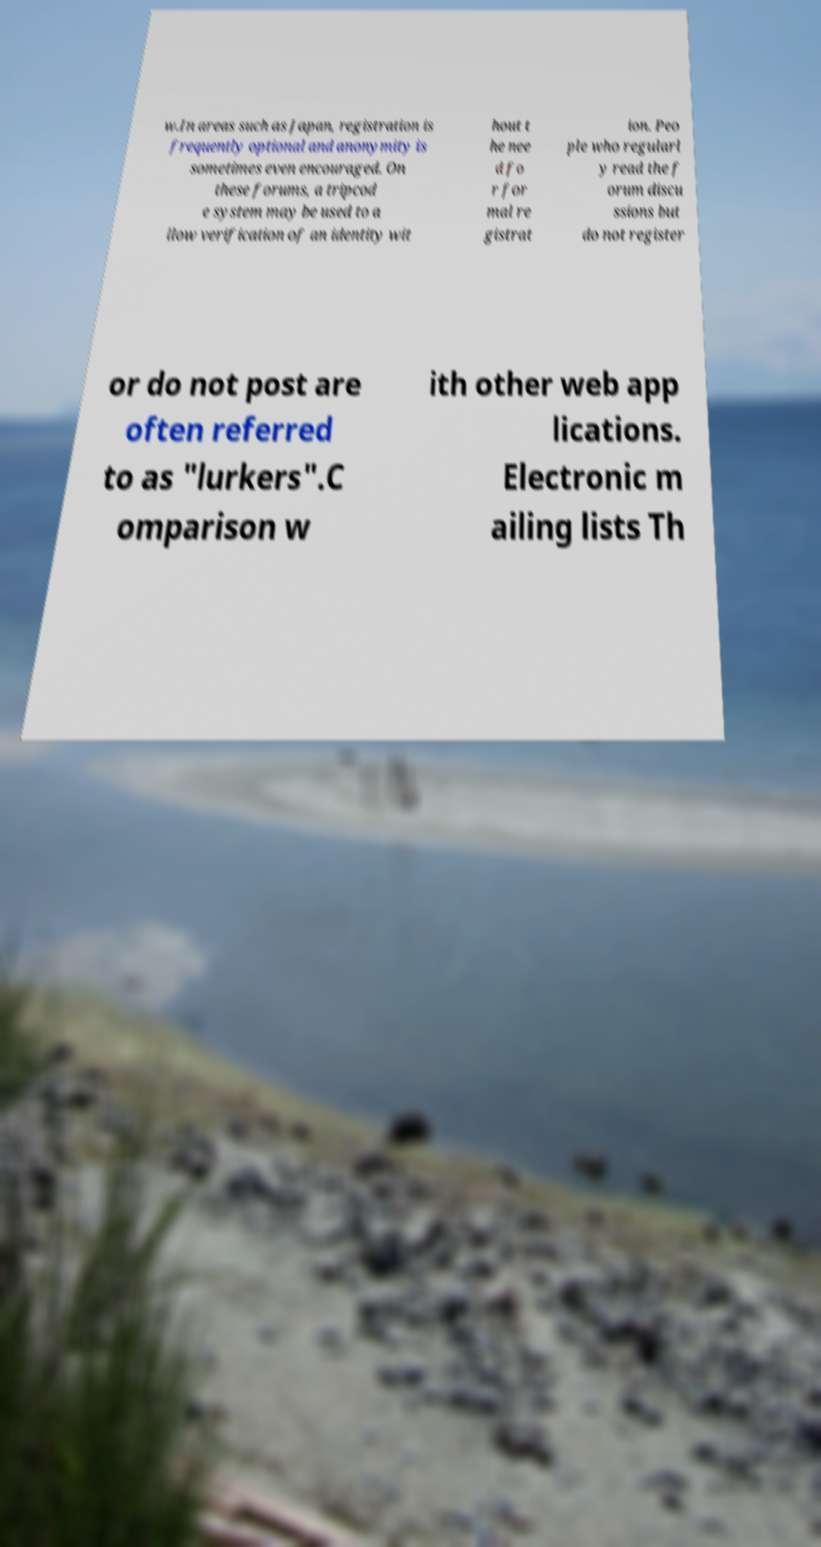I need the written content from this picture converted into text. Can you do that? w.In areas such as Japan, registration is frequently optional and anonymity is sometimes even encouraged. On these forums, a tripcod e system may be used to a llow verification of an identity wit hout t he nee d fo r for mal re gistrat ion. Peo ple who regularl y read the f orum discu ssions but do not register or do not post are often referred to as "lurkers".C omparison w ith other web app lications. Electronic m ailing lists Th 